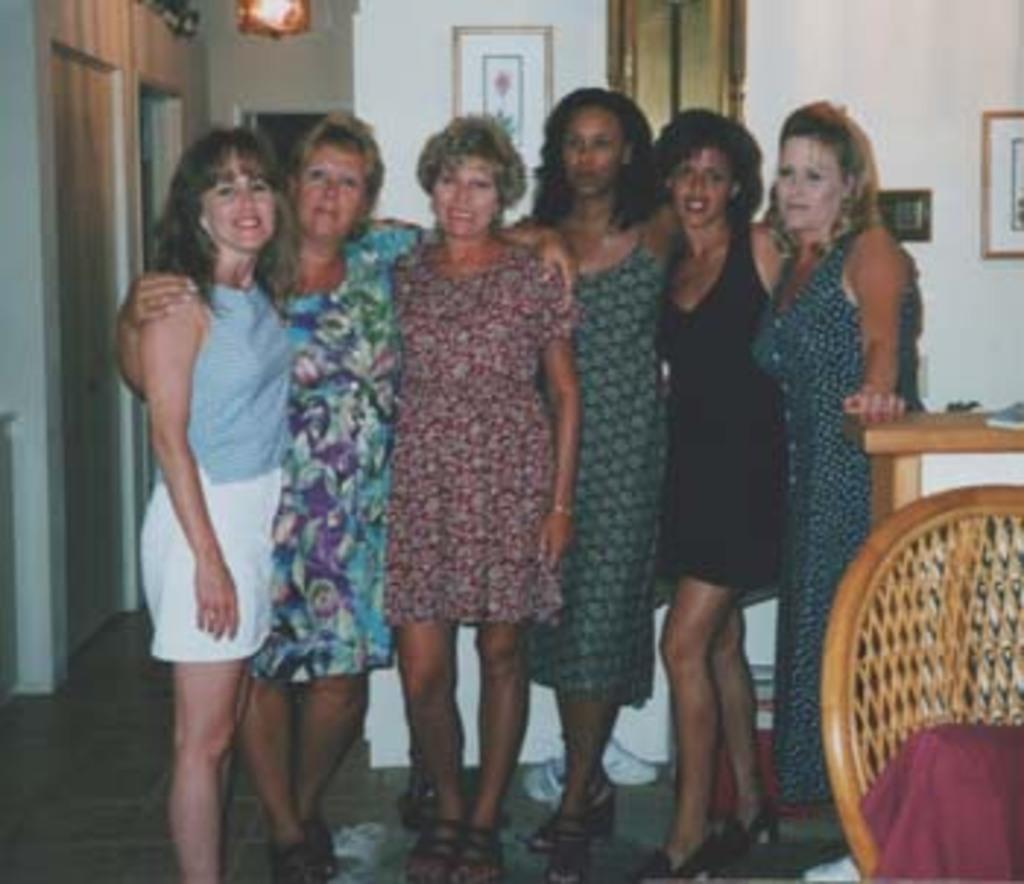In one or two sentences, can you explain what this image depicts? There is a group of persons standing as we can see in the middle of this image, and there is a wall in the background. There are some photo frames attached to it. There is a chair and a table on the right side of this image. 